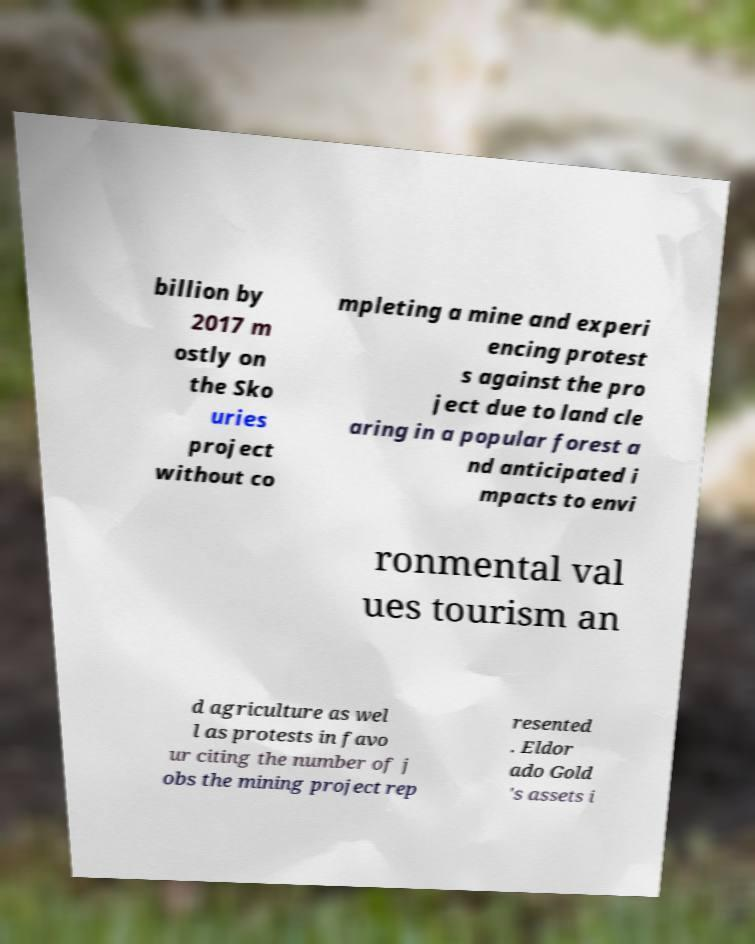Can you accurately transcribe the text from the provided image for me? billion by 2017 m ostly on the Sko uries project without co mpleting a mine and experi encing protest s against the pro ject due to land cle aring in a popular forest a nd anticipated i mpacts to envi ronmental val ues tourism an d agriculture as wel l as protests in favo ur citing the number of j obs the mining project rep resented . Eldor ado Gold 's assets i 